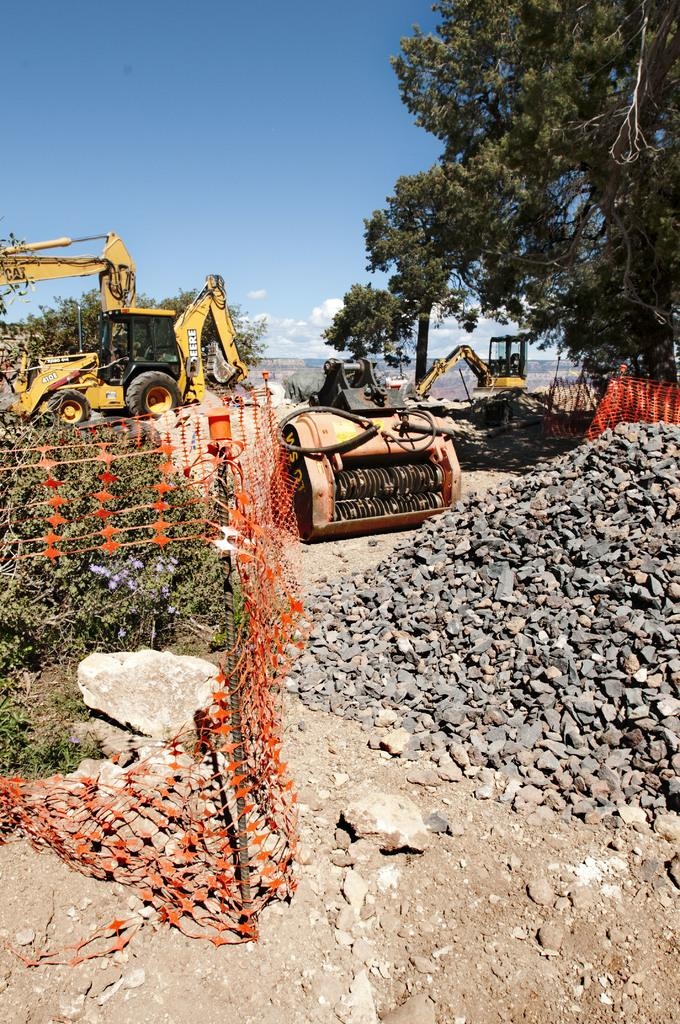What type of barrier can be seen in the image? There is a fence in the image. What type of natural elements are present in the image? Plants, rocks, stones, and trees are visible in the image. What type of vehicles can be seen in the image? Bulldozer vehicles are present in the image. What is the color of the sky in the background of the image? The sky is blue in the background of the image. What type of atmospheric phenomena can be seen in the sky? Clouds are present in the sky. What type of ship can be seen sailing in the background of the image? There is no ship present in the image; it features a fence, plants, rocks, stones, trees, bulldozer vehicles, a blue sky, and clouds. What type of detail can be seen on the fence in the image? The provided facts do not mention any specific details on the fence, so we cannot answer this question definitively. 